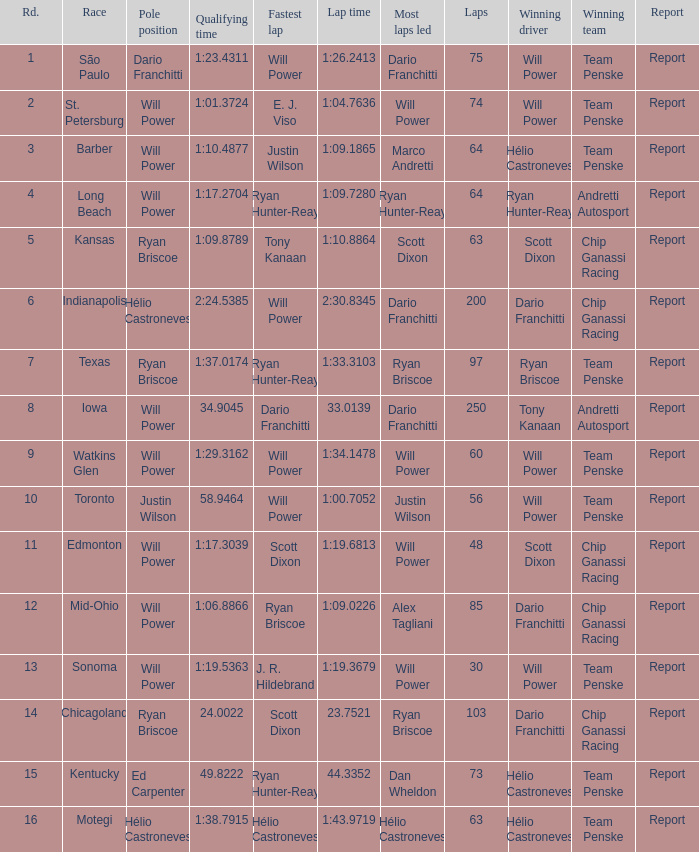Who was on the pole at Chicagoland? Ryan Briscoe. 